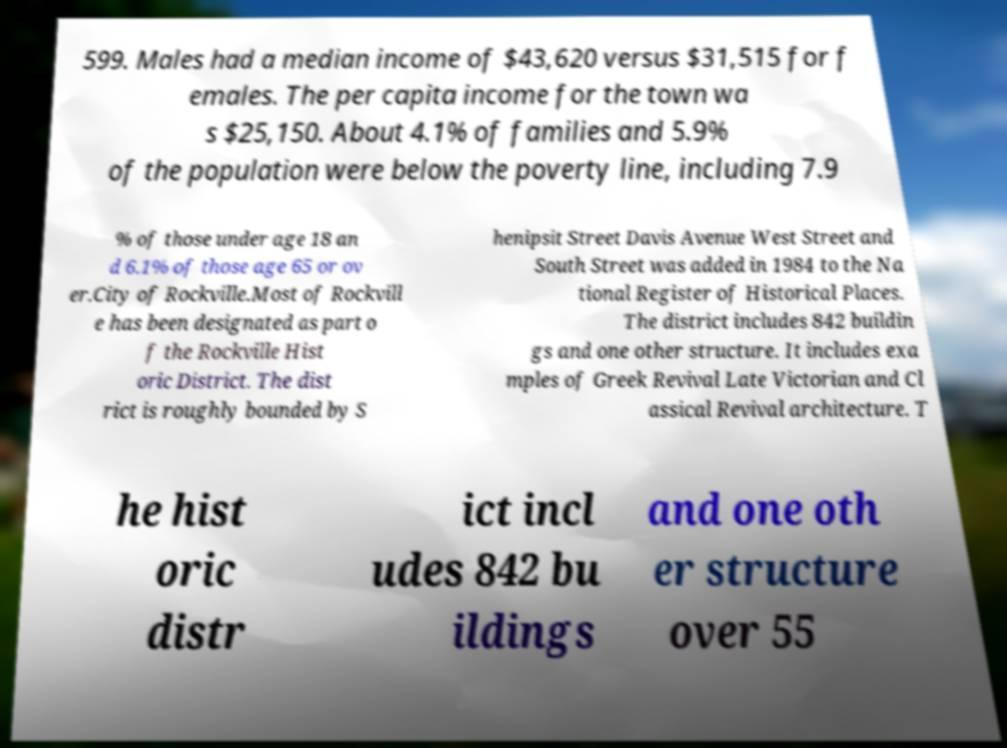Can you accurately transcribe the text from the provided image for me? 599. Males had a median income of $43,620 versus $31,515 for f emales. The per capita income for the town wa s $25,150. About 4.1% of families and 5.9% of the population were below the poverty line, including 7.9 % of those under age 18 an d 6.1% of those age 65 or ov er.City of Rockville.Most of Rockvill e has been designated as part o f the Rockville Hist oric District. The dist rict is roughly bounded by S henipsit Street Davis Avenue West Street and South Street was added in 1984 to the Na tional Register of Historical Places. The district includes 842 buildin gs and one other structure. It includes exa mples of Greek Revival Late Victorian and Cl assical Revival architecture. T he hist oric distr ict incl udes 842 bu ildings and one oth er structure over 55 